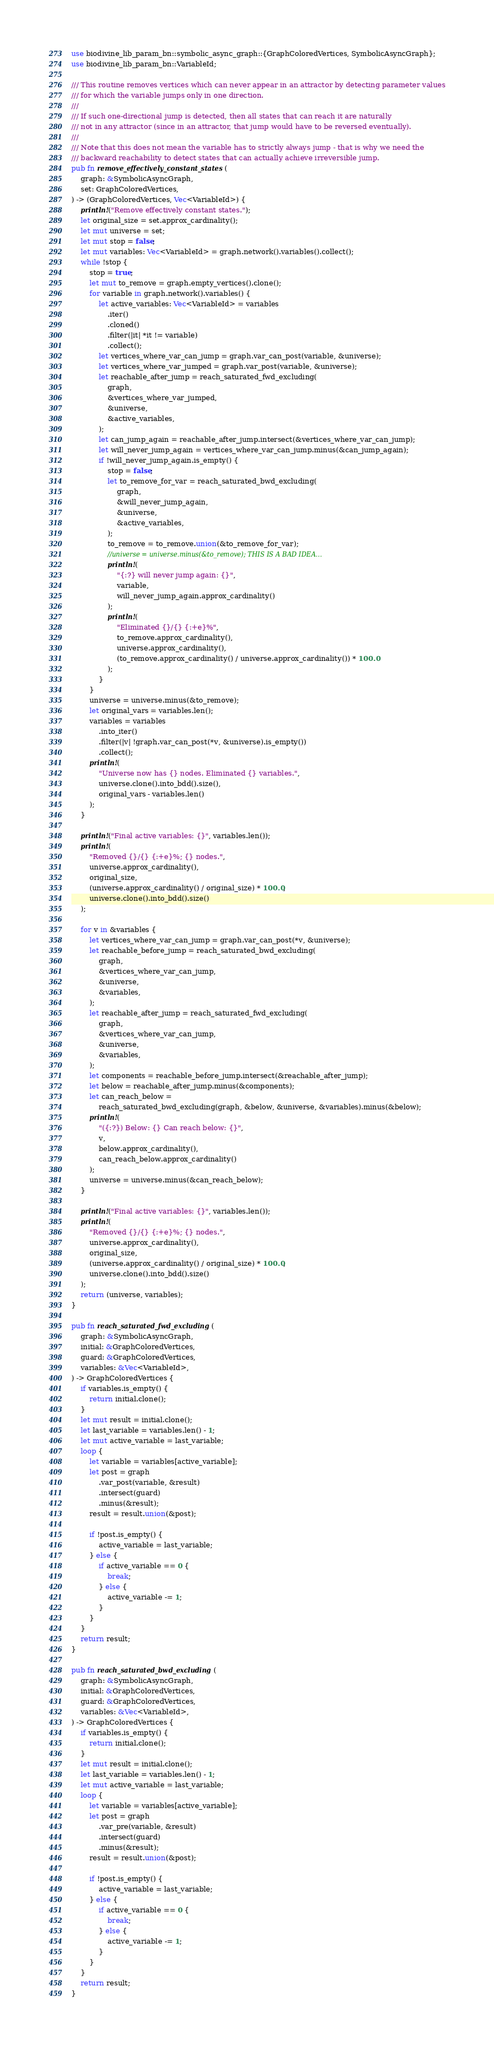Convert code to text. <code><loc_0><loc_0><loc_500><loc_500><_Rust_>use biodivine_lib_param_bn::symbolic_async_graph::{GraphColoredVertices, SymbolicAsyncGraph};
use biodivine_lib_param_bn::VariableId;

/// This routine removes vertices which can never appear in an attractor by detecting parameter values
/// for which the variable jumps only in one direction.
///
/// If such one-directional jump is detected, then all states that can reach it are naturally
/// not in any attractor (since in an attractor, that jump would have to be reversed eventually).
///
/// Note that this does not mean the variable has to strictly always jump - that is why we need the
/// backward reachability to detect states that can actually achieve irreversible jump.
pub fn remove_effectively_constant_states(
    graph: &SymbolicAsyncGraph,
    set: GraphColoredVertices,
) -> (GraphColoredVertices, Vec<VariableId>) {
    println!("Remove effectively constant states.");
    let original_size = set.approx_cardinality();
    let mut universe = set;
    let mut stop = false;
    let mut variables: Vec<VariableId> = graph.network().variables().collect();
    while !stop {
        stop = true;
        let mut to_remove = graph.empty_vertices().clone();
        for variable in graph.network().variables() {
            let active_variables: Vec<VariableId> = variables
                .iter()
                .cloned()
                .filter(|it| *it != variable)
                .collect();
            let vertices_where_var_can_jump = graph.var_can_post(variable, &universe);
            let vertices_where_var_jumped = graph.var_post(variable, &universe);
            let reachable_after_jump = reach_saturated_fwd_excluding(
                graph,
                &vertices_where_var_jumped,
                &universe,
                &active_variables,
            );
            let can_jump_again = reachable_after_jump.intersect(&vertices_where_var_can_jump);
            let will_never_jump_again = vertices_where_var_can_jump.minus(&can_jump_again);
            if !will_never_jump_again.is_empty() {
                stop = false;
                let to_remove_for_var = reach_saturated_bwd_excluding(
                    graph,
                    &will_never_jump_again,
                    &universe,
                    &active_variables,
                );
                to_remove = to_remove.union(&to_remove_for_var);
                //universe = universe.minus(&to_remove); THIS IS A BAD IDEA...
                println!(
                    "{:?} will never jump again: {}",
                    variable,
                    will_never_jump_again.approx_cardinality()
                );
                println!(
                    "Eliminated {}/{} {:+e}%",
                    to_remove.approx_cardinality(),
                    universe.approx_cardinality(),
                    (to_remove.approx_cardinality() / universe.approx_cardinality()) * 100.0
                );
            }
        }
        universe = universe.minus(&to_remove);
        let original_vars = variables.len();
        variables = variables
            .into_iter()
            .filter(|v| !graph.var_can_post(*v, &universe).is_empty())
            .collect();
        println!(
            "Universe now has {} nodes. Eliminated {} variables.",
            universe.clone().into_bdd().size(),
            original_vars - variables.len()
        );
    }

    println!("Final active variables: {}", variables.len());
    println!(
        "Removed {}/{} {:+e}%; {} nodes.",
        universe.approx_cardinality(),
        original_size,
        (universe.approx_cardinality() / original_size) * 100.0,
        universe.clone().into_bdd().size()
    );

    for v in &variables {
        let vertices_where_var_can_jump = graph.var_can_post(*v, &universe);
        let reachable_before_jump = reach_saturated_bwd_excluding(
            graph,
            &vertices_where_var_can_jump,
            &universe,
            &variables,
        );
        let reachable_after_jump = reach_saturated_fwd_excluding(
            graph,
            &vertices_where_var_can_jump,
            &universe,
            &variables,
        );
        let components = reachable_before_jump.intersect(&reachable_after_jump);
        let below = reachable_after_jump.minus(&components);
        let can_reach_below =
            reach_saturated_bwd_excluding(graph, &below, &universe, &variables).minus(&below);
        println!(
            "({:?}) Below: {} Can reach below: {}",
            v,
            below.approx_cardinality(),
            can_reach_below.approx_cardinality()
        );
        universe = universe.minus(&can_reach_below);
    }

    println!("Final active variables: {}", variables.len());
    println!(
        "Removed {}/{} {:+e}%; {} nodes.",
        universe.approx_cardinality(),
        original_size,
        (universe.approx_cardinality() / original_size) * 100.0,
        universe.clone().into_bdd().size()
    );
    return (universe, variables);
}

pub fn reach_saturated_fwd_excluding(
    graph: &SymbolicAsyncGraph,
    initial: &GraphColoredVertices,
    guard: &GraphColoredVertices,
    variables: &Vec<VariableId>,
) -> GraphColoredVertices {
    if variables.is_empty() {
        return initial.clone();
    }
    let mut result = initial.clone();
    let last_variable = variables.len() - 1;
    let mut active_variable = last_variable;
    loop {
        let variable = variables[active_variable];
        let post = graph
            .var_post(variable, &result)
            .intersect(guard)
            .minus(&result);
        result = result.union(&post);

        if !post.is_empty() {
            active_variable = last_variable;
        } else {
            if active_variable == 0 {
                break;
            } else {
                active_variable -= 1;
            }
        }
    }
    return result;
}

pub fn reach_saturated_bwd_excluding(
    graph: &SymbolicAsyncGraph,
    initial: &GraphColoredVertices,
    guard: &GraphColoredVertices,
    variables: &Vec<VariableId>,
) -> GraphColoredVertices {
    if variables.is_empty() {
        return initial.clone();
    }
    let mut result = initial.clone();
    let last_variable = variables.len() - 1;
    let mut active_variable = last_variable;
    loop {
        let variable = variables[active_variable];
        let post = graph
            .var_pre(variable, &result)
            .intersect(guard)
            .minus(&result);
        result = result.union(&post);

        if !post.is_empty() {
            active_variable = last_variable;
        } else {
            if active_variable == 0 {
                break;
            } else {
                active_variable -= 1;
            }
        }
    }
    return result;
}
</code> 